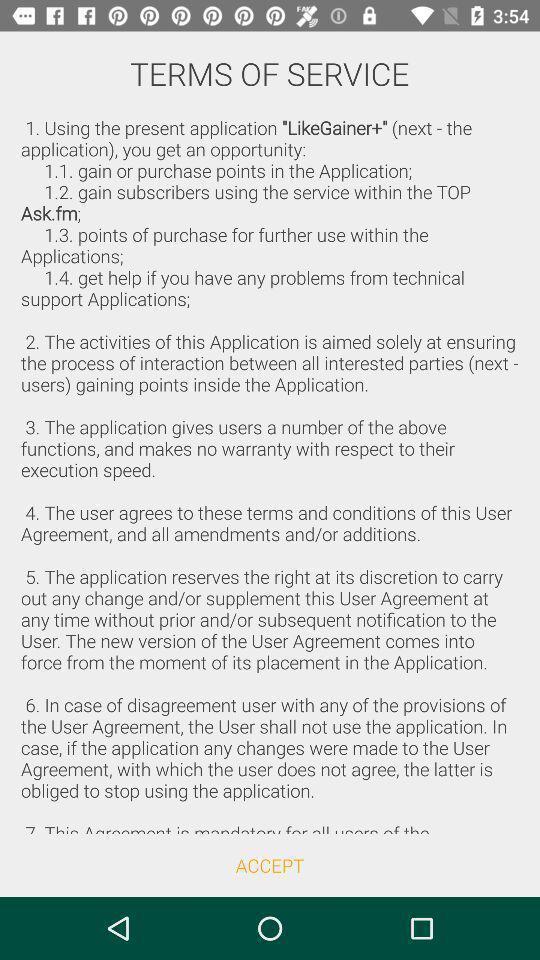Summarize the information in this screenshot. Terms and conditions page. 